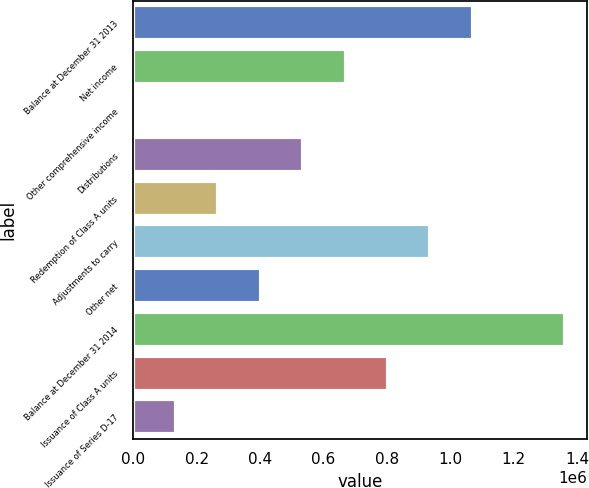<chart> <loc_0><loc_0><loc_500><loc_500><bar_chart><fcel>Balance at December 31 2013<fcel>Net income<fcel>Other comprehensive income<fcel>Distributions<fcel>Redemption of Class A units<fcel>Adjustments to carry<fcel>Other net<fcel>Balance at December 31 2014<fcel>Issuance of Class A units<fcel>Issuance of Series D-17<nl><fcel>1.07049e+06<fcel>669552<fcel>1323<fcel>535906<fcel>268614<fcel>936843<fcel>402260<fcel>1.36287e+06<fcel>803197<fcel>134969<nl></chart> 